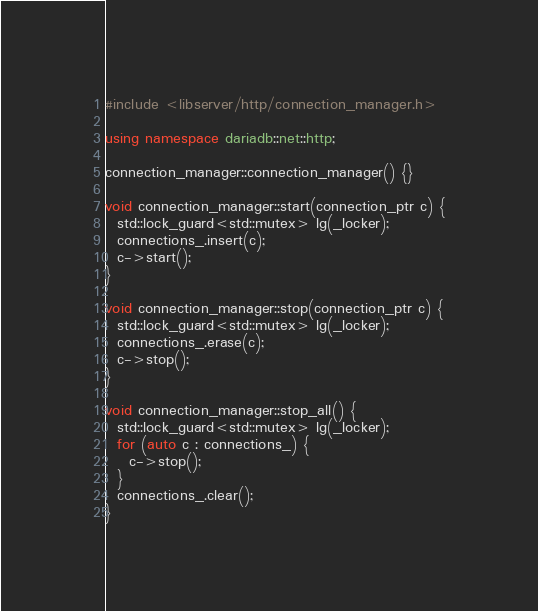<code> <loc_0><loc_0><loc_500><loc_500><_C++_>#include <libserver/http/connection_manager.h>

using namespace dariadb::net::http;

connection_manager::connection_manager() {}

void connection_manager::start(connection_ptr c) {
  std::lock_guard<std::mutex> lg(_locker);
  connections_.insert(c);
  c->start();
}

void connection_manager::stop(connection_ptr c) {
  std::lock_guard<std::mutex> lg(_locker);
  connections_.erase(c);
  c->stop();
}

void connection_manager::stop_all() {
  std::lock_guard<std::mutex> lg(_locker);
  for (auto c : connections_) {
    c->stop();
  }
  connections_.clear();
}
</code> 